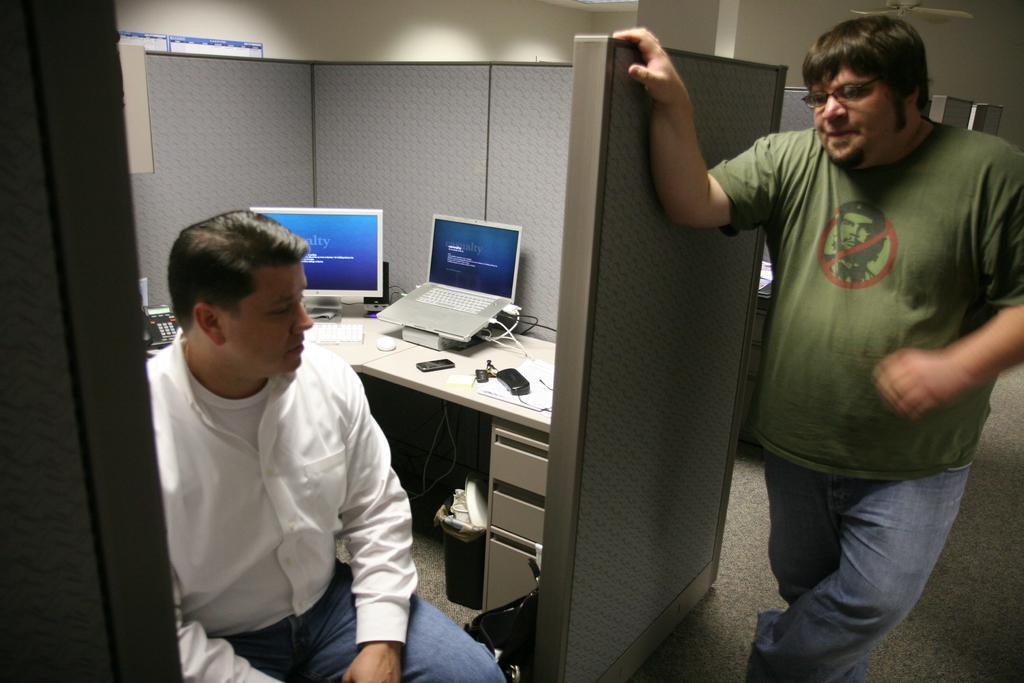In one or two sentences, can you explain what this image depicts? In the image we can see there is a man who is sitting on chair and another man is standing and on the table there is monitor and laptop. 